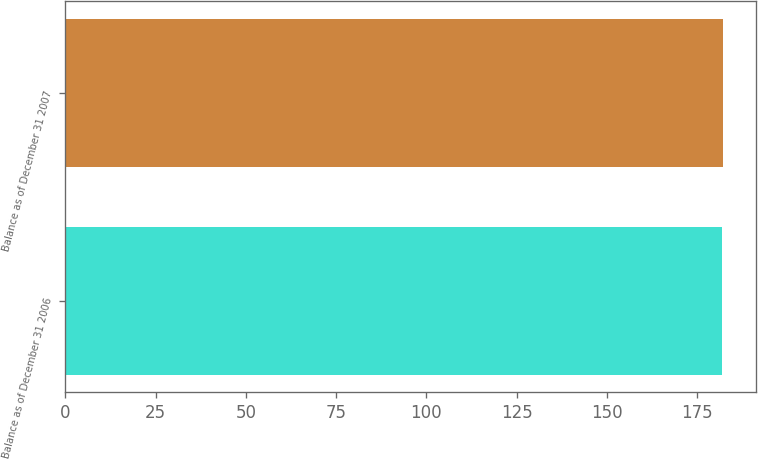Convert chart to OTSL. <chart><loc_0><loc_0><loc_500><loc_500><bar_chart><fcel>Balance as of December 31 2006<fcel>Balance as of December 31 2007<nl><fcel>182<fcel>182.1<nl></chart> 